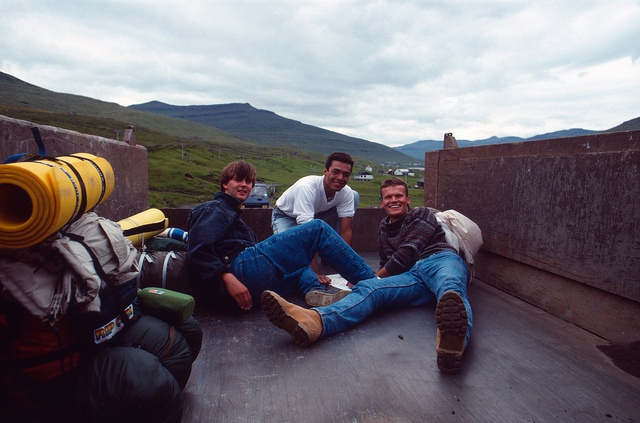Describe the objects in this image and their specific colors. I can see truck in lightgray, black, gray, and maroon tones, people in lightgray, black, navy, blue, and brown tones, people in lightgray, black, navy, maroon, and blue tones, backpack in lightgray, black, gray, darkgray, and maroon tones, and people in lightgray, black, gray, and maroon tones in this image. 